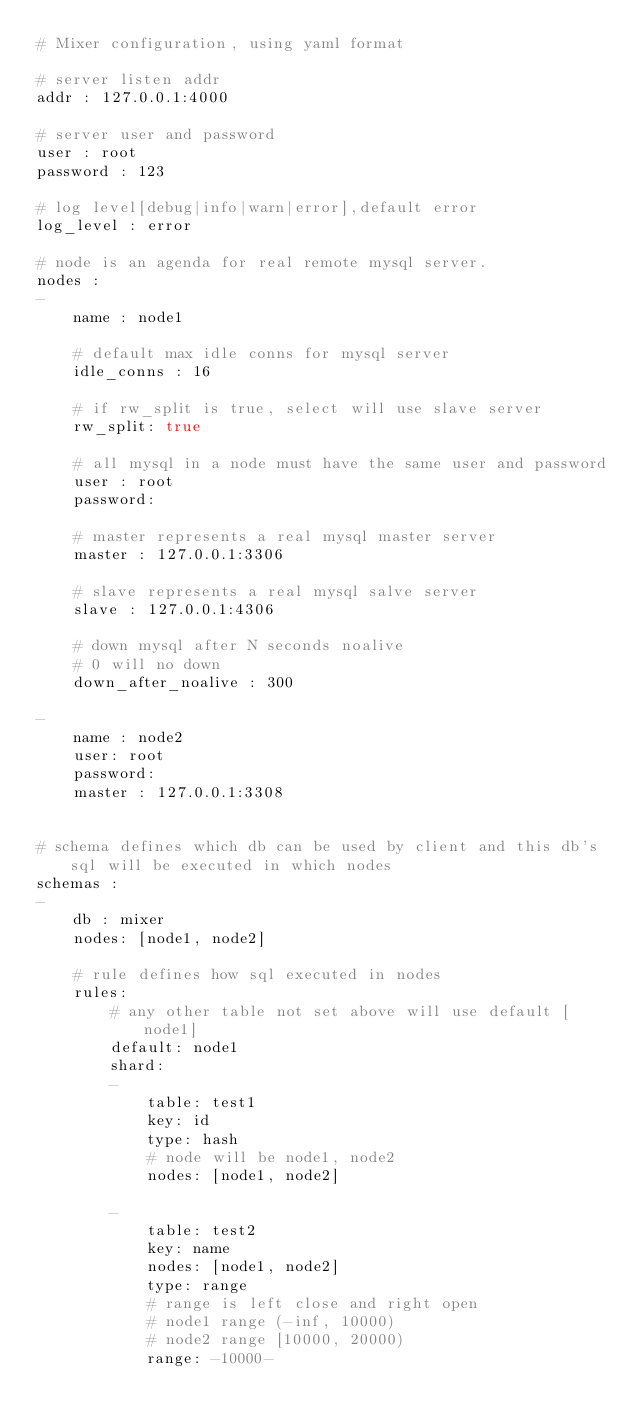<code> <loc_0><loc_0><loc_500><loc_500><_YAML_># Mixer configuration, using yaml format

# server listen addr
addr : 127.0.0.1:4000

# server user and password
user : root
password : 123

# log level[debug|info|warn|error],default error
log_level : error

# node is an agenda for real remote mysql server.
nodes :
- 
    name : node1 

    # default max idle conns for mysql server
    idle_conns : 16

    # if rw_split is true, select will use slave server
    rw_split: true

    # all mysql in a node must have the same user and password
    user : root
    password: 

    # master represents a real mysql master server 
    master : 127.0.0.1:3306

    # slave represents a real mysql salve server 
    slave : 127.0.0.1:4306

    # down mysql after N seconds noalive
    # 0 will no down
    down_after_noalive : 300

-
    name : node2 
    user: root 
    password: 
    master : 127.0.0.1:3308


# schema defines which db can be used by client and this db's sql will be executed in which nodes
schemas :
-
    db : mixer 
    nodes: [node1, node2]

    # rule defines how sql executed in nodes
    rules:
        # any other table not set above will use default [node1]
        default: node1
        shard:
        -   
            table: test1 
            key: id
            type: hash
            # node will be node1, node2
            nodes: [node1, node2]

        -
            table: test2 
            key: name
            nodes: [node1, node2]
            type: range
            # range is left close and right open
            # node1 range (-inf, 10000)
            # node2 range [10000, 20000)
            range: -10000-
</code> 